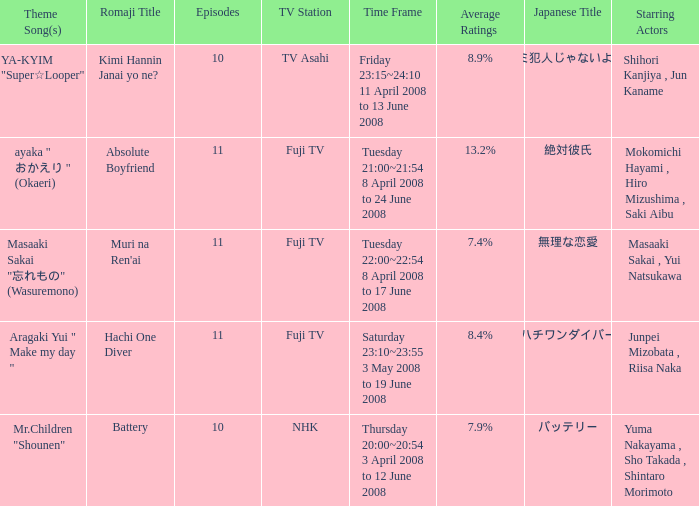What is the average rating for tv asahi? 8.9%. 